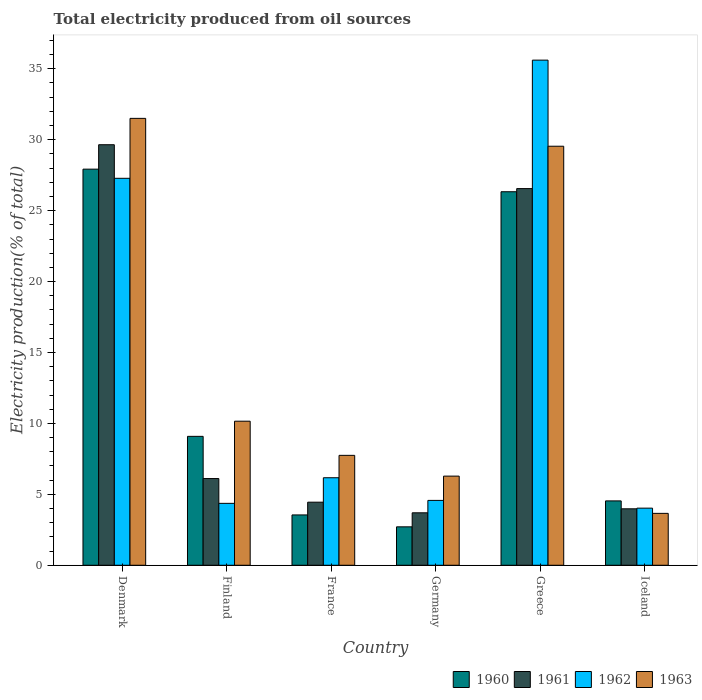How many different coloured bars are there?
Offer a terse response. 4. Are the number of bars per tick equal to the number of legend labels?
Offer a terse response. Yes. How many bars are there on the 2nd tick from the left?
Make the answer very short. 4. How many bars are there on the 1st tick from the right?
Your answer should be compact. 4. What is the label of the 6th group of bars from the left?
Keep it short and to the point. Iceland. In how many cases, is the number of bars for a given country not equal to the number of legend labels?
Provide a succinct answer. 0. What is the total electricity produced in 1961 in Germany?
Offer a terse response. 3.7. Across all countries, what is the maximum total electricity produced in 1960?
Your answer should be very brief. 27.92. Across all countries, what is the minimum total electricity produced in 1962?
Your response must be concise. 4.03. In which country was the total electricity produced in 1962 minimum?
Your answer should be very brief. Iceland. What is the total total electricity produced in 1963 in the graph?
Make the answer very short. 88.89. What is the difference between the total electricity produced in 1960 in Denmark and that in Iceland?
Your answer should be very brief. 23.39. What is the difference between the total electricity produced in 1961 in France and the total electricity produced in 1960 in Denmark?
Make the answer very short. -23.48. What is the average total electricity produced in 1962 per country?
Make the answer very short. 13.67. What is the difference between the total electricity produced of/in 1963 and total electricity produced of/in 1961 in Germany?
Offer a very short reply. 2.59. In how many countries, is the total electricity produced in 1963 greater than 26 %?
Make the answer very short. 2. What is the ratio of the total electricity produced in 1960 in Denmark to that in France?
Your response must be concise. 7.87. What is the difference between the highest and the second highest total electricity produced in 1963?
Give a very brief answer. -19.38. What is the difference between the highest and the lowest total electricity produced in 1960?
Keep it short and to the point. 25.22. Are all the bars in the graph horizontal?
Provide a succinct answer. No. Are the values on the major ticks of Y-axis written in scientific E-notation?
Give a very brief answer. No. Does the graph contain grids?
Make the answer very short. No. What is the title of the graph?
Keep it short and to the point. Total electricity produced from oil sources. Does "1973" appear as one of the legend labels in the graph?
Your answer should be very brief. No. What is the label or title of the X-axis?
Offer a very short reply. Country. What is the label or title of the Y-axis?
Make the answer very short. Electricity production(% of total). What is the Electricity production(% of total) in 1960 in Denmark?
Make the answer very short. 27.92. What is the Electricity production(% of total) in 1961 in Denmark?
Offer a very short reply. 29.65. What is the Electricity production(% of total) in 1962 in Denmark?
Your answer should be very brief. 27.28. What is the Electricity production(% of total) of 1963 in Denmark?
Your response must be concise. 31.51. What is the Electricity production(% of total) in 1960 in Finland?
Your answer should be compact. 9.09. What is the Electricity production(% of total) of 1961 in Finland?
Your response must be concise. 6.11. What is the Electricity production(% of total) of 1962 in Finland?
Give a very brief answer. 4.36. What is the Electricity production(% of total) of 1963 in Finland?
Give a very brief answer. 10.16. What is the Electricity production(% of total) of 1960 in France?
Provide a short and direct response. 3.55. What is the Electricity production(% of total) of 1961 in France?
Provide a short and direct response. 4.45. What is the Electricity production(% of total) of 1962 in France?
Make the answer very short. 6.17. What is the Electricity production(% of total) in 1963 in France?
Offer a terse response. 7.75. What is the Electricity production(% of total) in 1960 in Germany?
Keep it short and to the point. 2.71. What is the Electricity production(% of total) in 1961 in Germany?
Provide a short and direct response. 3.7. What is the Electricity production(% of total) of 1962 in Germany?
Your answer should be very brief. 4.57. What is the Electricity production(% of total) in 1963 in Germany?
Provide a short and direct response. 6.28. What is the Electricity production(% of total) of 1960 in Greece?
Provide a short and direct response. 26.33. What is the Electricity production(% of total) of 1961 in Greece?
Your response must be concise. 26.55. What is the Electricity production(% of total) of 1962 in Greece?
Your answer should be compact. 35.61. What is the Electricity production(% of total) in 1963 in Greece?
Provide a short and direct response. 29.54. What is the Electricity production(% of total) in 1960 in Iceland?
Your answer should be very brief. 4.54. What is the Electricity production(% of total) in 1961 in Iceland?
Keep it short and to the point. 3.98. What is the Electricity production(% of total) of 1962 in Iceland?
Offer a terse response. 4.03. What is the Electricity production(% of total) in 1963 in Iceland?
Your answer should be compact. 3.66. Across all countries, what is the maximum Electricity production(% of total) in 1960?
Provide a short and direct response. 27.92. Across all countries, what is the maximum Electricity production(% of total) of 1961?
Offer a terse response. 29.65. Across all countries, what is the maximum Electricity production(% of total) of 1962?
Provide a succinct answer. 35.61. Across all countries, what is the maximum Electricity production(% of total) of 1963?
Provide a succinct answer. 31.51. Across all countries, what is the minimum Electricity production(% of total) in 1960?
Make the answer very short. 2.71. Across all countries, what is the minimum Electricity production(% of total) of 1961?
Provide a succinct answer. 3.7. Across all countries, what is the minimum Electricity production(% of total) in 1962?
Ensure brevity in your answer.  4.03. Across all countries, what is the minimum Electricity production(% of total) in 1963?
Make the answer very short. 3.66. What is the total Electricity production(% of total) of 1960 in the graph?
Make the answer very short. 74.14. What is the total Electricity production(% of total) of 1961 in the graph?
Your answer should be compact. 74.44. What is the total Electricity production(% of total) in 1962 in the graph?
Ensure brevity in your answer.  82.02. What is the total Electricity production(% of total) of 1963 in the graph?
Offer a terse response. 88.89. What is the difference between the Electricity production(% of total) of 1960 in Denmark and that in Finland?
Provide a short and direct response. 18.84. What is the difference between the Electricity production(% of total) of 1961 in Denmark and that in Finland?
Keep it short and to the point. 23.53. What is the difference between the Electricity production(% of total) in 1962 in Denmark and that in Finland?
Ensure brevity in your answer.  22.91. What is the difference between the Electricity production(% of total) in 1963 in Denmark and that in Finland?
Make the answer very short. 21.35. What is the difference between the Electricity production(% of total) in 1960 in Denmark and that in France?
Make the answer very short. 24.38. What is the difference between the Electricity production(% of total) of 1961 in Denmark and that in France?
Provide a short and direct response. 25.2. What is the difference between the Electricity production(% of total) in 1962 in Denmark and that in France?
Make the answer very short. 21.11. What is the difference between the Electricity production(% of total) of 1963 in Denmark and that in France?
Your response must be concise. 23.76. What is the difference between the Electricity production(% of total) of 1960 in Denmark and that in Germany?
Offer a terse response. 25.22. What is the difference between the Electricity production(% of total) of 1961 in Denmark and that in Germany?
Make the answer very short. 25.95. What is the difference between the Electricity production(% of total) of 1962 in Denmark and that in Germany?
Your answer should be very brief. 22.71. What is the difference between the Electricity production(% of total) of 1963 in Denmark and that in Germany?
Give a very brief answer. 25.22. What is the difference between the Electricity production(% of total) in 1960 in Denmark and that in Greece?
Make the answer very short. 1.59. What is the difference between the Electricity production(% of total) of 1961 in Denmark and that in Greece?
Your answer should be compact. 3.09. What is the difference between the Electricity production(% of total) in 1962 in Denmark and that in Greece?
Ensure brevity in your answer.  -8.33. What is the difference between the Electricity production(% of total) in 1963 in Denmark and that in Greece?
Ensure brevity in your answer.  1.96. What is the difference between the Electricity production(% of total) in 1960 in Denmark and that in Iceland?
Provide a short and direct response. 23.39. What is the difference between the Electricity production(% of total) in 1961 in Denmark and that in Iceland?
Make the answer very short. 25.67. What is the difference between the Electricity production(% of total) in 1962 in Denmark and that in Iceland?
Ensure brevity in your answer.  23.25. What is the difference between the Electricity production(% of total) in 1963 in Denmark and that in Iceland?
Your answer should be compact. 27.85. What is the difference between the Electricity production(% of total) of 1960 in Finland and that in France?
Your response must be concise. 5.54. What is the difference between the Electricity production(% of total) in 1961 in Finland and that in France?
Your answer should be compact. 1.67. What is the difference between the Electricity production(% of total) in 1962 in Finland and that in France?
Provide a short and direct response. -1.8. What is the difference between the Electricity production(% of total) in 1963 in Finland and that in France?
Provide a short and direct response. 2.41. What is the difference between the Electricity production(% of total) in 1960 in Finland and that in Germany?
Keep it short and to the point. 6.38. What is the difference between the Electricity production(% of total) of 1961 in Finland and that in Germany?
Offer a very short reply. 2.41. What is the difference between the Electricity production(% of total) of 1962 in Finland and that in Germany?
Provide a succinct answer. -0.21. What is the difference between the Electricity production(% of total) of 1963 in Finland and that in Germany?
Make the answer very short. 3.87. What is the difference between the Electricity production(% of total) of 1960 in Finland and that in Greece?
Your answer should be compact. -17.24. What is the difference between the Electricity production(% of total) of 1961 in Finland and that in Greece?
Your answer should be compact. -20.44. What is the difference between the Electricity production(% of total) in 1962 in Finland and that in Greece?
Offer a very short reply. -31.25. What is the difference between the Electricity production(% of total) in 1963 in Finland and that in Greece?
Provide a short and direct response. -19.38. What is the difference between the Electricity production(% of total) of 1960 in Finland and that in Iceland?
Make the answer very short. 4.55. What is the difference between the Electricity production(% of total) of 1961 in Finland and that in Iceland?
Your response must be concise. 2.13. What is the difference between the Electricity production(% of total) of 1962 in Finland and that in Iceland?
Your answer should be compact. 0.34. What is the difference between the Electricity production(% of total) of 1963 in Finland and that in Iceland?
Give a very brief answer. 6.5. What is the difference between the Electricity production(% of total) of 1960 in France and that in Germany?
Your response must be concise. 0.84. What is the difference between the Electricity production(% of total) of 1961 in France and that in Germany?
Your response must be concise. 0.75. What is the difference between the Electricity production(% of total) in 1962 in France and that in Germany?
Give a very brief answer. 1.6. What is the difference between the Electricity production(% of total) in 1963 in France and that in Germany?
Ensure brevity in your answer.  1.46. What is the difference between the Electricity production(% of total) in 1960 in France and that in Greece?
Provide a succinct answer. -22.78. What is the difference between the Electricity production(% of total) of 1961 in France and that in Greece?
Offer a very short reply. -22.11. What is the difference between the Electricity production(% of total) of 1962 in France and that in Greece?
Offer a terse response. -29.44. What is the difference between the Electricity production(% of total) in 1963 in France and that in Greece?
Offer a very short reply. -21.79. What is the difference between the Electricity production(% of total) in 1960 in France and that in Iceland?
Provide a short and direct response. -0.99. What is the difference between the Electricity production(% of total) of 1961 in France and that in Iceland?
Offer a very short reply. 0.47. What is the difference between the Electricity production(% of total) of 1962 in France and that in Iceland?
Give a very brief answer. 2.14. What is the difference between the Electricity production(% of total) of 1963 in France and that in Iceland?
Make the answer very short. 4.09. What is the difference between the Electricity production(% of total) of 1960 in Germany and that in Greece?
Offer a very short reply. -23.62. What is the difference between the Electricity production(% of total) of 1961 in Germany and that in Greece?
Provide a short and direct response. -22.86. What is the difference between the Electricity production(% of total) of 1962 in Germany and that in Greece?
Give a very brief answer. -31.04. What is the difference between the Electricity production(% of total) in 1963 in Germany and that in Greece?
Offer a very short reply. -23.26. What is the difference between the Electricity production(% of total) of 1960 in Germany and that in Iceland?
Ensure brevity in your answer.  -1.83. What is the difference between the Electricity production(% of total) in 1961 in Germany and that in Iceland?
Offer a terse response. -0.28. What is the difference between the Electricity production(% of total) of 1962 in Germany and that in Iceland?
Make the answer very short. 0.55. What is the difference between the Electricity production(% of total) in 1963 in Germany and that in Iceland?
Provide a succinct answer. 2.63. What is the difference between the Electricity production(% of total) in 1960 in Greece and that in Iceland?
Make the answer very short. 21.79. What is the difference between the Electricity production(% of total) in 1961 in Greece and that in Iceland?
Make the answer very short. 22.57. What is the difference between the Electricity production(% of total) of 1962 in Greece and that in Iceland?
Your answer should be very brief. 31.58. What is the difference between the Electricity production(% of total) in 1963 in Greece and that in Iceland?
Offer a very short reply. 25.88. What is the difference between the Electricity production(% of total) of 1960 in Denmark and the Electricity production(% of total) of 1961 in Finland?
Give a very brief answer. 21.81. What is the difference between the Electricity production(% of total) of 1960 in Denmark and the Electricity production(% of total) of 1962 in Finland?
Keep it short and to the point. 23.56. What is the difference between the Electricity production(% of total) of 1960 in Denmark and the Electricity production(% of total) of 1963 in Finland?
Give a very brief answer. 17.77. What is the difference between the Electricity production(% of total) of 1961 in Denmark and the Electricity production(% of total) of 1962 in Finland?
Provide a succinct answer. 25.28. What is the difference between the Electricity production(% of total) in 1961 in Denmark and the Electricity production(% of total) in 1963 in Finland?
Your response must be concise. 19.49. What is the difference between the Electricity production(% of total) in 1962 in Denmark and the Electricity production(% of total) in 1963 in Finland?
Your response must be concise. 17.12. What is the difference between the Electricity production(% of total) of 1960 in Denmark and the Electricity production(% of total) of 1961 in France?
Offer a terse response. 23.48. What is the difference between the Electricity production(% of total) in 1960 in Denmark and the Electricity production(% of total) in 1962 in France?
Your answer should be very brief. 21.75. What is the difference between the Electricity production(% of total) in 1960 in Denmark and the Electricity production(% of total) in 1963 in France?
Your answer should be very brief. 20.18. What is the difference between the Electricity production(% of total) of 1961 in Denmark and the Electricity production(% of total) of 1962 in France?
Your response must be concise. 23.48. What is the difference between the Electricity production(% of total) of 1961 in Denmark and the Electricity production(% of total) of 1963 in France?
Give a very brief answer. 21.9. What is the difference between the Electricity production(% of total) in 1962 in Denmark and the Electricity production(% of total) in 1963 in France?
Provide a succinct answer. 19.53. What is the difference between the Electricity production(% of total) of 1960 in Denmark and the Electricity production(% of total) of 1961 in Germany?
Offer a terse response. 24.23. What is the difference between the Electricity production(% of total) in 1960 in Denmark and the Electricity production(% of total) in 1962 in Germany?
Offer a very short reply. 23.35. What is the difference between the Electricity production(% of total) in 1960 in Denmark and the Electricity production(% of total) in 1963 in Germany?
Offer a very short reply. 21.64. What is the difference between the Electricity production(% of total) in 1961 in Denmark and the Electricity production(% of total) in 1962 in Germany?
Provide a succinct answer. 25.07. What is the difference between the Electricity production(% of total) in 1961 in Denmark and the Electricity production(% of total) in 1963 in Germany?
Provide a succinct answer. 23.36. What is the difference between the Electricity production(% of total) of 1962 in Denmark and the Electricity production(% of total) of 1963 in Germany?
Make the answer very short. 20.99. What is the difference between the Electricity production(% of total) of 1960 in Denmark and the Electricity production(% of total) of 1961 in Greece?
Give a very brief answer. 1.37. What is the difference between the Electricity production(% of total) in 1960 in Denmark and the Electricity production(% of total) in 1962 in Greece?
Offer a very short reply. -7.69. What is the difference between the Electricity production(% of total) of 1960 in Denmark and the Electricity production(% of total) of 1963 in Greece?
Your response must be concise. -1.62. What is the difference between the Electricity production(% of total) of 1961 in Denmark and the Electricity production(% of total) of 1962 in Greece?
Ensure brevity in your answer.  -5.96. What is the difference between the Electricity production(% of total) of 1961 in Denmark and the Electricity production(% of total) of 1963 in Greece?
Provide a short and direct response. 0.11. What is the difference between the Electricity production(% of total) in 1962 in Denmark and the Electricity production(% of total) in 1963 in Greece?
Your answer should be compact. -2.26. What is the difference between the Electricity production(% of total) of 1960 in Denmark and the Electricity production(% of total) of 1961 in Iceland?
Your answer should be compact. 23.94. What is the difference between the Electricity production(% of total) of 1960 in Denmark and the Electricity production(% of total) of 1962 in Iceland?
Keep it short and to the point. 23.9. What is the difference between the Electricity production(% of total) of 1960 in Denmark and the Electricity production(% of total) of 1963 in Iceland?
Provide a succinct answer. 24.27. What is the difference between the Electricity production(% of total) of 1961 in Denmark and the Electricity production(% of total) of 1962 in Iceland?
Your response must be concise. 25.62. What is the difference between the Electricity production(% of total) of 1961 in Denmark and the Electricity production(% of total) of 1963 in Iceland?
Keep it short and to the point. 25.99. What is the difference between the Electricity production(% of total) in 1962 in Denmark and the Electricity production(% of total) in 1963 in Iceland?
Give a very brief answer. 23.62. What is the difference between the Electricity production(% of total) in 1960 in Finland and the Electricity production(% of total) in 1961 in France?
Your answer should be very brief. 4.64. What is the difference between the Electricity production(% of total) in 1960 in Finland and the Electricity production(% of total) in 1962 in France?
Your answer should be compact. 2.92. What is the difference between the Electricity production(% of total) of 1960 in Finland and the Electricity production(% of total) of 1963 in France?
Offer a very short reply. 1.34. What is the difference between the Electricity production(% of total) of 1961 in Finland and the Electricity production(% of total) of 1962 in France?
Your answer should be compact. -0.06. What is the difference between the Electricity production(% of total) in 1961 in Finland and the Electricity production(% of total) in 1963 in France?
Your response must be concise. -1.64. What is the difference between the Electricity production(% of total) of 1962 in Finland and the Electricity production(% of total) of 1963 in France?
Make the answer very short. -3.38. What is the difference between the Electricity production(% of total) in 1960 in Finland and the Electricity production(% of total) in 1961 in Germany?
Provide a succinct answer. 5.39. What is the difference between the Electricity production(% of total) of 1960 in Finland and the Electricity production(% of total) of 1962 in Germany?
Your answer should be very brief. 4.51. What is the difference between the Electricity production(% of total) of 1960 in Finland and the Electricity production(% of total) of 1963 in Germany?
Provide a succinct answer. 2.8. What is the difference between the Electricity production(% of total) of 1961 in Finland and the Electricity production(% of total) of 1962 in Germany?
Give a very brief answer. 1.54. What is the difference between the Electricity production(% of total) in 1961 in Finland and the Electricity production(% of total) in 1963 in Germany?
Make the answer very short. -0.17. What is the difference between the Electricity production(% of total) of 1962 in Finland and the Electricity production(% of total) of 1963 in Germany?
Make the answer very short. -1.92. What is the difference between the Electricity production(% of total) of 1960 in Finland and the Electricity production(% of total) of 1961 in Greece?
Give a very brief answer. -17.47. What is the difference between the Electricity production(% of total) in 1960 in Finland and the Electricity production(% of total) in 1962 in Greece?
Your answer should be very brief. -26.52. What is the difference between the Electricity production(% of total) of 1960 in Finland and the Electricity production(% of total) of 1963 in Greece?
Ensure brevity in your answer.  -20.45. What is the difference between the Electricity production(% of total) in 1961 in Finland and the Electricity production(% of total) in 1962 in Greece?
Offer a terse response. -29.5. What is the difference between the Electricity production(% of total) in 1961 in Finland and the Electricity production(% of total) in 1963 in Greece?
Your answer should be very brief. -23.43. What is the difference between the Electricity production(% of total) in 1962 in Finland and the Electricity production(% of total) in 1963 in Greece?
Provide a short and direct response. -25.18. What is the difference between the Electricity production(% of total) of 1960 in Finland and the Electricity production(% of total) of 1961 in Iceland?
Your answer should be compact. 5.11. What is the difference between the Electricity production(% of total) of 1960 in Finland and the Electricity production(% of total) of 1962 in Iceland?
Provide a succinct answer. 5.06. What is the difference between the Electricity production(% of total) of 1960 in Finland and the Electricity production(% of total) of 1963 in Iceland?
Keep it short and to the point. 5.43. What is the difference between the Electricity production(% of total) in 1961 in Finland and the Electricity production(% of total) in 1962 in Iceland?
Your answer should be very brief. 2.09. What is the difference between the Electricity production(% of total) of 1961 in Finland and the Electricity production(% of total) of 1963 in Iceland?
Offer a very short reply. 2.45. What is the difference between the Electricity production(% of total) of 1962 in Finland and the Electricity production(% of total) of 1963 in Iceland?
Your answer should be very brief. 0.71. What is the difference between the Electricity production(% of total) of 1960 in France and the Electricity production(% of total) of 1961 in Germany?
Give a very brief answer. -0.15. What is the difference between the Electricity production(% of total) in 1960 in France and the Electricity production(% of total) in 1962 in Germany?
Provide a short and direct response. -1.02. What is the difference between the Electricity production(% of total) of 1960 in France and the Electricity production(% of total) of 1963 in Germany?
Provide a succinct answer. -2.74. What is the difference between the Electricity production(% of total) in 1961 in France and the Electricity production(% of total) in 1962 in Germany?
Make the answer very short. -0.13. What is the difference between the Electricity production(% of total) of 1961 in France and the Electricity production(% of total) of 1963 in Germany?
Offer a very short reply. -1.84. What is the difference between the Electricity production(% of total) in 1962 in France and the Electricity production(% of total) in 1963 in Germany?
Offer a terse response. -0.11. What is the difference between the Electricity production(% of total) of 1960 in France and the Electricity production(% of total) of 1961 in Greece?
Your response must be concise. -23.01. What is the difference between the Electricity production(% of total) in 1960 in France and the Electricity production(% of total) in 1962 in Greece?
Give a very brief answer. -32.06. What is the difference between the Electricity production(% of total) of 1960 in France and the Electricity production(% of total) of 1963 in Greece?
Your response must be concise. -25.99. What is the difference between the Electricity production(% of total) in 1961 in France and the Electricity production(% of total) in 1962 in Greece?
Your answer should be compact. -31.16. What is the difference between the Electricity production(% of total) of 1961 in France and the Electricity production(% of total) of 1963 in Greece?
Your response must be concise. -25.09. What is the difference between the Electricity production(% of total) in 1962 in France and the Electricity production(% of total) in 1963 in Greece?
Make the answer very short. -23.37. What is the difference between the Electricity production(% of total) of 1960 in France and the Electricity production(% of total) of 1961 in Iceland?
Provide a succinct answer. -0.43. What is the difference between the Electricity production(% of total) in 1960 in France and the Electricity production(% of total) in 1962 in Iceland?
Make the answer very short. -0.48. What is the difference between the Electricity production(% of total) in 1960 in France and the Electricity production(% of total) in 1963 in Iceland?
Provide a succinct answer. -0.11. What is the difference between the Electricity production(% of total) in 1961 in France and the Electricity production(% of total) in 1962 in Iceland?
Provide a succinct answer. 0.42. What is the difference between the Electricity production(% of total) of 1961 in France and the Electricity production(% of total) of 1963 in Iceland?
Offer a terse response. 0.79. What is the difference between the Electricity production(% of total) of 1962 in France and the Electricity production(% of total) of 1963 in Iceland?
Offer a very short reply. 2.51. What is the difference between the Electricity production(% of total) in 1960 in Germany and the Electricity production(% of total) in 1961 in Greece?
Give a very brief answer. -23.85. What is the difference between the Electricity production(% of total) of 1960 in Germany and the Electricity production(% of total) of 1962 in Greece?
Offer a terse response. -32.9. What is the difference between the Electricity production(% of total) in 1960 in Germany and the Electricity production(% of total) in 1963 in Greece?
Your answer should be compact. -26.83. What is the difference between the Electricity production(% of total) of 1961 in Germany and the Electricity production(% of total) of 1962 in Greece?
Offer a very short reply. -31.91. What is the difference between the Electricity production(% of total) in 1961 in Germany and the Electricity production(% of total) in 1963 in Greece?
Make the answer very short. -25.84. What is the difference between the Electricity production(% of total) of 1962 in Germany and the Electricity production(% of total) of 1963 in Greece?
Provide a succinct answer. -24.97. What is the difference between the Electricity production(% of total) of 1960 in Germany and the Electricity production(% of total) of 1961 in Iceland?
Make the answer very short. -1.27. What is the difference between the Electricity production(% of total) of 1960 in Germany and the Electricity production(% of total) of 1962 in Iceland?
Make the answer very short. -1.32. What is the difference between the Electricity production(% of total) in 1960 in Germany and the Electricity production(% of total) in 1963 in Iceland?
Offer a terse response. -0.95. What is the difference between the Electricity production(% of total) of 1961 in Germany and the Electricity production(% of total) of 1962 in Iceland?
Provide a succinct answer. -0.33. What is the difference between the Electricity production(% of total) of 1961 in Germany and the Electricity production(% of total) of 1963 in Iceland?
Give a very brief answer. 0.04. What is the difference between the Electricity production(% of total) of 1962 in Germany and the Electricity production(% of total) of 1963 in Iceland?
Ensure brevity in your answer.  0.91. What is the difference between the Electricity production(% of total) of 1960 in Greece and the Electricity production(% of total) of 1961 in Iceland?
Keep it short and to the point. 22.35. What is the difference between the Electricity production(% of total) of 1960 in Greece and the Electricity production(% of total) of 1962 in Iceland?
Make the answer very short. 22.31. What is the difference between the Electricity production(% of total) in 1960 in Greece and the Electricity production(% of total) in 1963 in Iceland?
Give a very brief answer. 22.67. What is the difference between the Electricity production(% of total) of 1961 in Greece and the Electricity production(% of total) of 1962 in Iceland?
Your answer should be very brief. 22.53. What is the difference between the Electricity production(% of total) of 1961 in Greece and the Electricity production(% of total) of 1963 in Iceland?
Keep it short and to the point. 22.9. What is the difference between the Electricity production(% of total) of 1962 in Greece and the Electricity production(% of total) of 1963 in Iceland?
Keep it short and to the point. 31.95. What is the average Electricity production(% of total) of 1960 per country?
Give a very brief answer. 12.36. What is the average Electricity production(% of total) of 1961 per country?
Offer a terse response. 12.41. What is the average Electricity production(% of total) in 1962 per country?
Offer a very short reply. 13.67. What is the average Electricity production(% of total) in 1963 per country?
Your response must be concise. 14.82. What is the difference between the Electricity production(% of total) in 1960 and Electricity production(% of total) in 1961 in Denmark?
Offer a very short reply. -1.72. What is the difference between the Electricity production(% of total) of 1960 and Electricity production(% of total) of 1962 in Denmark?
Provide a short and direct response. 0.65. What is the difference between the Electricity production(% of total) in 1960 and Electricity production(% of total) in 1963 in Denmark?
Ensure brevity in your answer.  -3.58. What is the difference between the Electricity production(% of total) in 1961 and Electricity production(% of total) in 1962 in Denmark?
Provide a short and direct response. 2.37. What is the difference between the Electricity production(% of total) in 1961 and Electricity production(% of total) in 1963 in Denmark?
Give a very brief answer. -1.86. What is the difference between the Electricity production(% of total) of 1962 and Electricity production(% of total) of 1963 in Denmark?
Offer a terse response. -4.23. What is the difference between the Electricity production(% of total) in 1960 and Electricity production(% of total) in 1961 in Finland?
Your answer should be very brief. 2.98. What is the difference between the Electricity production(% of total) of 1960 and Electricity production(% of total) of 1962 in Finland?
Ensure brevity in your answer.  4.72. What is the difference between the Electricity production(% of total) of 1960 and Electricity production(% of total) of 1963 in Finland?
Keep it short and to the point. -1.07. What is the difference between the Electricity production(% of total) in 1961 and Electricity production(% of total) in 1962 in Finland?
Your answer should be compact. 1.75. What is the difference between the Electricity production(% of total) in 1961 and Electricity production(% of total) in 1963 in Finland?
Your answer should be compact. -4.04. What is the difference between the Electricity production(% of total) in 1962 and Electricity production(% of total) in 1963 in Finland?
Offer a very short reply. -5.79. What is the difference between the Electricity production(% of total) in 1960 and Electricity production(% of total) in 1961 in France?
Offer a very short reply. -0.9. What is the difference between the Electricity production(% of total) in 1960 and Electricity production(% of total) in 1962 in France?
Offer a very short reply. -2.62. What is the difference between the Electricity production(% of total) in 1960 and Electricity production(% of total) in 1963 in France?
Your answer should be compact. -4.2. What is the difference between the Electricity production(% of total) of 1961 and Electricity production(% of total) of 1962 in France?
Your answer should be very brief. -1.72. What is the difference between the Electricity production(% of total) in 1961 and Electricity production(% of total) in 1963 in France?
Your response must be concise. -3.3. What is the difference between the Electricity production(% of total) in 1962 and Electricity production(% of total) in 1963 in France?
Your answer should be compact. -1.58. What is the difference between the Electricity production(% of total) in 1960 and Electricity production(% of total) in 1961 in Germany?
Provide a short and direct response. -0.99. What is the difference between the Electricity production(% of total) of 1960 and Electricity production(% of total) of 1962 in Germany?
Offer a terse response. -1.86. What is the difference between the Electricity production(% of total) of 1960 and Electricity production(% of total) of 1963 in Germany?
Make the answer very short. -3.58. What is the difference between the Electricity production(% of total) of 1961 and Electricity production(% of total) of 1962 in Germany?
Give a very brief answer. -0.87. What is the difference between the Electricity production(% of total) in 1961 and Electricity production(% of total) in 1963 in Germany?
Keep it short and to the point. -2.59. What is the difference between the Electricity production(% of total) in 1962 and Electricity production(% of total) in 1963 in Germany?
Give a very brief answer. -1.71. What is the difference between the Electricity production(% of total) of 1960 and Electricity production(% of total) of 1961 in Greece?
Provide a short and direct response. -0.22. What is the difference between the Electricity production(% of total) in 1960 and Electricity production(% of total) in 1962 in Greece?
Ensure brevity in your answer.  -9.28. What is the difference between the Electricity production(% of total) in 1960 and Electricity production(% of total) in 1963 in Greece?
Give a very brief answer. -3.21. What is the difference between the Electricity production(% of total) in 1961 and Electricity production(% of total) in 1962 in Greece?
Your answer should be compact. -9.06. What is the difference between the Electricity production(% of total) of 1961 and Electricity production(% of total) of 1963 in Greece?
Your answer should be very brief. -2.99. What is the difference between the Electricity production(% of total) in 1962 and Electricity production(% of total) in 1963 in Greece?
Your answer should be compact. 6.07. What is the difference between the Electricity production(% of total) in 1960 and Electricity production(% of total) in 1961 in Iceland?
Your response must be concise. 0.56. What is the difference between the Electricity production(% of total) in 1960 and Electricity production(% of total) in 1962 in Iceland?
Your response must be concise. 0.51. What is the difference between the Electricity production(% of total) in 1960 and Electricity production(% of total) in 1963 in Iceland?
Your answer should be very brief. 0.88. What is the difference between the Electricity production(% of total) in 1961 and Electricity production(% of total) in 1962 in Iceland?
Make the answer very short. -0.05. What is the difference between the Electricity production(% of total) of 1961 and Electricity production(% of total) of 1963 in Iceland?
Offer a terse response. 0.32. What is the difference between the Electricity production(% of total) of 1962 and Electricity production(% of total) of 1963 in Iceland?
Your answer should be compact. 0.37. What is the ratio of the Electricity production(% of total) of 1960 in Denmark to that in Finland?
Provide a succinct answer. 3.07. What is the ratio of the Electricity production(% of total) in 1961 in Denmark to that in Finland?
Ensure brevity in your answer.  4.85. What is the ratio of the Electricity production(% of total) in 1962 in Denmark to that in Finland?
Give a very brief answer. 6.25. What is the ratio of the Electricity production(% of total) of 1963 in Denmark to that in Finland?
Your response must be concise. 3.1. What is the ratio of the Electricity production(% of total) in 1960 in Denmark to that in France?
Give a very brief answer. 7.87. What is the ratio of the Electricity production(% of total) in 1961 in Denmark to that in France?
Give a very brief answer. 6.67. What is the ratio of the Electricity production(% of total) of 1962 in Denmark to that in France?
Keep it short and to the point. 4.42. What is the ratio of the Electricity production(% of total) of 1963 in Denmark to that in France?
Make the answer very short. 4.07. What is the ratio of the Electricity production(% of total) in 1960 in Denmark to that in Germany?
Offer a terse response. 10.31. What is the ratio of the Electricity production(% of total) in 1961 in Denmark to that in Germany?
Give a very brief answer. 8.02. What is the ratio of the Electricity production(% of total) in 1962 in Denmark to that in Germany?
Offer a terse response. 5.97. What is the ratio of the Electricity production(% of total) of 1963 in Denmark to that in Germany?
Offer a terse response. 5.01. What is the ratio of the Electricity production(% of total) in 1960 in Denmark to that in Greece?
Keep it short and to the point. 1.06. What is the ratio of the Electricity production(% of total) in 1961 in Denmark to that in Greece?
Give a very brief answer. 1.12. What is the ratio of the Electricity production(% of total) in 1962 in Denmark to that in Greece?
Keep it short and to the point. 0.77. What is the ratio of the Electricity production(% of total) of 1963 in Denmark to that in Greece?
Provide a short and direct response. 1.07. What is the ratio of the Electricity production(% of total) in 1960 in Denmark to that in Iceland?
Provide a succinct answer. 6.15. What is the ratio of the Electricity production(% of total) of 1961 in Denmark to that in Iceland?
Ensure brevity in your answer.  7.45. What is the ratio of the Electricity production(% of total) in 1962 in Denmark to that in Iceland?
Keep it short and to the point. 6.78. What is the ratio of the Electricity production(% of total) in 1963 in Denmark to that in Iceland?
Your answer should be very brief. 8.61. What is the ratio of the Electricity production(% of total) of 1960 in Finland to that in France?
Make the answer very short. 2.56. What is the ratio of the Electricity production(% of total) in 1961 in Finland to that in France?
Give a very brief answer. 1.37. What is the ratio of the Electricity production(% of total) in 1962 in Finland to that in France?
Offer a terse response. 0.71. What is the ratio of the Electricity production(% of total) of 1963 in Finland to that in France?
Provide a succinct answer. 1.31. What is the ratio of the Electricity production(% of total) of 1960 in Finland to that in Germany?
Ensure brevity in your answer.  3.36. What is the ratio of the Electricity production(% of total) of 1961 in Finland to that in Germany?
Make the answer very short. 1.65. What is the ratio of the Electricity production(% of total) in 1962 in Finland to that in Germany?
Your answer should be very brief. 0.95. What is the ratio of the Electricity production(% of total) of 1963 in Finland to that in Germany?
Provide a succinct answer. 1.62. What is the ratio of the Electricity production(% of total) of 1960 in Finland to that in Greece?
Provide a succinct answer. 0.35. What is the ratio of the Electricity production(% of total) in 1961 in Finland to that in Greece?
Your response must be concise. 0.23. What is the ratio of the Electricity production(% of total) in 1962 in Finland to that in Greece?
Make the answer very short. 0.12. What is the ratio of the Electricity production(% of total) in 1963 in Finland to that in Greece?
Keep it short and to the point. 0.34. What is the ratio of the Electricity production(% of total) in 1960 in Finland to that in Iceland?
Ensure brevity in your answer.  2. What is the ratio of the Electricity production(% of total) in 1961 in Finland to that in Iceland?
Offer a very short reply. 1.54. What is the ratio of the Electricity production(% of total) in 1962 in Finland to that in Iceland?
Your response must be concise. 1.08. What is the ratio of the Electricity production(% of total) in 1963 in Finland to that in Iceland?
Offer a very short reply. 2.78. What is the ratio of the Electricity production(% of total) of 1960 in France to that in Germany?
Ensure brevity in your answer.  1.31. What is the ratio of the Electricity production(% of total) in 1961 in France to that in Germany?
Offer a terse response. 1.2. What is the ratio of the Electricity production(% of total) of 1962 in France to that in Germany?
Your answer should be compact. 1.35. What is the ratio of the Electricity production(% of total) of 1963 in France to that in Germany?
Provide a short and direct response. 1.23. What is the ratio of the Electricity production(% of total) in 1960 in France to that in Greece?
Provide a short and direct response. 0.13. What is the ratio of the Electricity production(% of total) of 1961 in France to that in Greece?
Give a very brief answer. 0.17. What is the ratio of the Electricity production(% of total) of 1962 in France to that in Greece?
Make the answer very short. 0.17. What is the ratio of the Electricity production(% of total) in 1963 in France to that in Greece?
Offer a very short reply. 0.26. What is the ratio of the Electricity production(% of total) of 1960 in France to that in Iceland?
Provide a succinct answer. 0.78. What is the ratio of the Electricity production(% of total) of 1961 in France to that in Iceland?
Give a very brief answer. 1.12. What is the ratio of the Electricity production(% of total) of 1962 in France to that in Iceland?
Keep it short and to the point. 1.53. What is the ratio of the Electricity production(% of total) of 1963 in France to that in Iceland?
Make the answer very short. 2.12. What is the ratio of the Electricity production(% of total) in 1960 in Germany to that in Greece?
Offer a terse response. 0.1. What is the ratio of the Electricity production(% of total) of 1961 in Germany to that in Greece?
Ensure brevity in your answer.  0.14. What is the ratio of the Electricity production(% of total) of 1962 in Germany to that in Greece?
Provide a succinct answer. 0.13. What is the ratio of the Electricity production(% of total) in 1963 in Germany to that in Greece?
Your answer should be very brief. 0.21. What is the ratio of the Electricity production(% of total) in 1960 in Germany to that in Iceland?
Your response must be concise. 0.6. What is the ratio of the Electricity production(% of total) in 1961 in Germany to that in Iceland?
Your response must be concise. 0.93. What is the ratio of the Electricity production(% of total) in 1962 in Germany to that in Iceland?
Your answer should be compact. 1.14. What is the ratio of the Electricity production(% of total) of 1963 in Germany to that in Iceland?
Your answer should be compact. 1.72. What is the ratio of the Electricity production(% of total) in 1960 in Greece to that in Iceland?
Offer a terse response. 5.8. What is the ratio of the Electricity production(% of total) in 1961 in Greece to that in Iceland?
Keep it short and to the point. 6.67. What is the ratio of the Electricity production(% of total) of 1962 in Greece to that in Iceland?
Offer a very short reply. 8.85. What is the ratio of the Electricity production(% of total) of 1963 in Greece to that in Iceland?
Provide a short and direct response. 8.07. What is the difference between the highest and the second highest Electricity production(% of total) of 1960?
Ensure brevity in your answer.  1.59. What is the difference between the highest and the second highest Electricity production(% of total) in 1961?
Provide a short and direct response. 3.09. What is the difference between the highest and the second highest Electricity production(% of total) of 1962?
Make the answer very short. 8.33. What is the difference between the highest and the second highest Electricity production(% of total) of 1963?
Provide a succinct answer. 1.96. What is the difference between the highest and the lowest Electricity production(% of total) of 1960?
Keep it short and to the point. 25.22. What is the difference between the highest and the lowest Electricity production(% of total) of 1961?
Offer a very short reply. 25.95. What is the difference between the highest and the lowest Electricity production(% of total) of 1962?
Ensure brevity in your answer.  31.58. What is the difference between the highest and the lowest Electricity production(% of total) of 1963?
Your response must be concise. 27.85. 